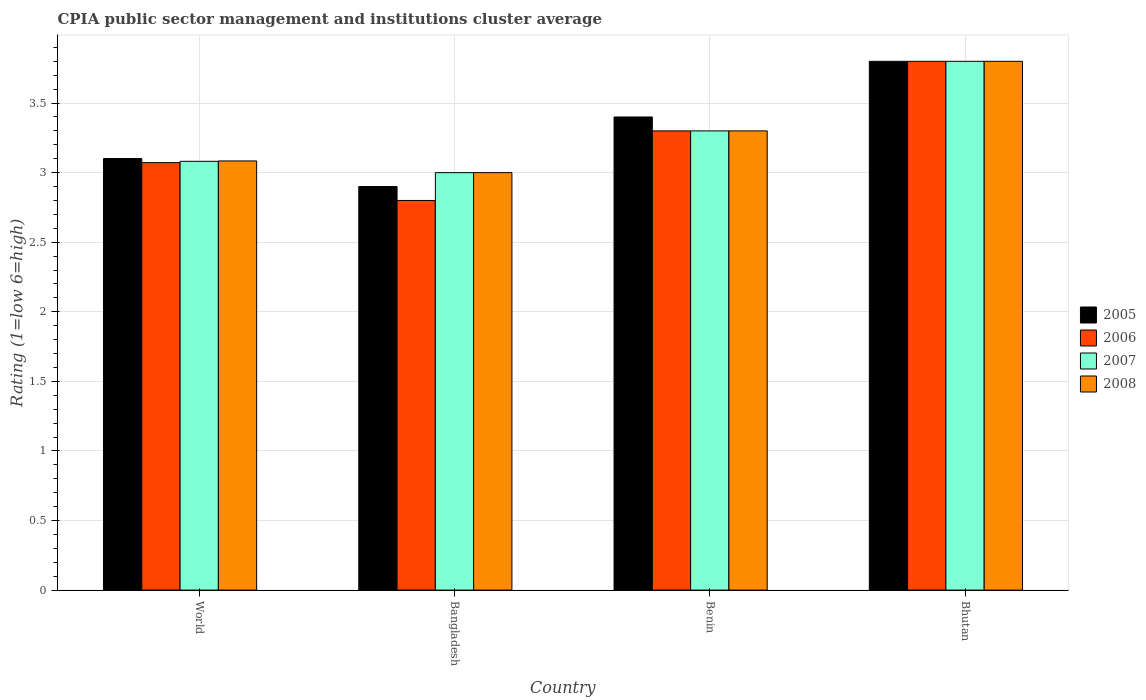How many groups of bars are there?
Give a very brief answer. 4. Are the number of bars per tick equal to the number of legend labels?
Your response must be concise. Yes. How many bars are there on the 1st tick from the right?
Provide a succinct answer. 4. What is the label of the 2nd group of bars from the left?
Provide a short and direct response. Bangladesh. What is the CPIA rating in 2006 in Benin?
Ensure brevity in your answer.  3.3. In which country was the CPIA rating in 2007 maximum?
Your answer should be very brief. Bhutan. What is the total CPIA rating in 2008 in the graph?
Give a very brief answer. 13.18. What is the difference between the CPIA rating in 2005 in Bhutan and that in World?
Ensure brevity in your answer.  0.7. What is the difference between the CPIA rating in 2007 in Bangladesh and the CPIA rating in 2006 in Bhutan?
Your response must be concise. -0.8. What is the average CPIA rating in 2006 per country?
Your answer should be compact. 3.24. In how many countries, is the CPIA rating in 2007 greater than 2.3?
Make the answer very short. 4. What is the ratio of the CPIA rating in 2007 in Bangladesh to that in Bhutan?
Keep it short and to the point. 0.79. Is the CPIA rating in 2007 in Bangladesh less than that in Bhutan?
Keep it short and to the point. Yes. Is the difference between the CPIA rating in 2007 in Bangladesh and World greater than the difference between the CPIA rating in 2008 in Bangladesh and World?
Provide a short and direct response. Yes. What is the difference between the highest and the second highest CPIA rating in 2005?
Provide a short and direct response. -0.4. What is the difference between the highest and the lowest CPIA rating in 2005?
Your answer should be compact. 0.9. Is it the case that in every country, the sum of the CPIA rating in 2006 and CPIA rating in 2007 is greater than the CPIA rating in 2005?
Your response must be concise. Yes. How many bars are there?
Offer a terse response. 16. Are all the bars in the graph horizontal?
Your answer should be compact. No. How many countries are there in the graph?
Make the answer very short. 4. What is the difference between two consecutive major ticks on the Y-axis?
Provide a succinct answer. 0.5. Are the values on the major ticks of Y-axis written in scientific E-notation?
Offer a very short reply. No. Does the graph contain any zero values?
Offer a very short reply. No. Does the graph contain grids?
Offer a terse response. Yes. How many legend labels are there?
Provide a succinct answer. 4. What is the title of the graph?
Ensure brevity in your answer.  CPIA public sector management and institutions cluster average. Does "1963" appear as one of the legend labels in the graph?
Offer a very short reply. No. What is the label or title of the Y-axis?
Provide a succinct answer. Rating (1=low 6=high). What is the Rating (1=low 6=high) of 2005 in World?
Your response must be concise. 3.1. What is the Rating (1=low 6=high) of 2006 in World?
Your answer should be very brief. 3.07. What is the Rating (1=low 6=high) of 2007 in World?
Provide a succinct answer. 3.08. What is the Rating (1=low 6=high) in 2008 in World?
Offer a terse response. 3.08. What is the Rating (1=low 6=high) of 2006 in Bangladesh?
Ensure brevity in your answer.  2.8. What is the Rating (1=low 6=high) of 2007 in Bangladesh?
Give a very brief answer. 3. What is the Rating (1=low 6=high) of 2008 in Bangladesh?
Your answer should be compact. 3. What is the Rating (1=low 6=high) in 2006 in Benin?
Your answer should be very brief. 3.3. What is the Rating (1=low 6=high) in 2008 in Benin?
Ensure brevity in your answer.  3.3. What is the Rating (1=low 6=high) in 2005 in Bhutan?
Ensure brevity in your answer.  3.8. What is the Rating (1=low 6=high) in 2008 in Bhutan?
Your answer should be very brief. 3.8. Across all countries, what is the maximum Rating (1=low 6=high) of 2005?
Your response must be concise. 3.8. Across all countries, what is the maximum Rating (1=low 6=high) in 2006?
Your answer should be very brief. 3.8. Across all countries, what is the minimum Rating (1=low 6=high) of 2006?
Offer a terse response. 2.8. Across all countries, what is the minimum Rating (1=low 6=high) in 2007?
Ensure brevity in your answer.  3. What is the total Rating (1=low 6=high) in 2005 in the graph?
Provide a succinct answer. 13.2. What is the total Rating (1=low 6=high) in 2006 in the graph?
Offer a very short reply. 12.97. What is the total Rating (1=low 6=high) of 2007 in the graph?
Your answer should be very brief. 13.18. What is the total Rating (1=low 6=high) of 2008 in the graph?
Your response must be concise. 13.18. What is the difference between the Rating (1=low 6=high) of 2005 in World and that in Bangladesh?
Make the answer very short. 0.2. What is the difference between the Rating (1=low 6=high) in 2006 in World and that in Bangladesh?
Offer a very short reply. 0.27. What is the difference between the Rating (1=low 6=high) of 2007 in World and that in Bangladesh?
Ensure brevity in your answer.  0.08. What is the difference between the Rating (1=low 6=high) in 2008 in World and that in Bangladesh?
Keep it short and to the point. 0.08. What is the difference between the Rating (1=low 6=high) in 2005 in World and that in Benin?
Provide a short and direct response. -0.3. What is the difference between the Rating (1=low 6=high) of 2006 in World and that in Benin?
Keep it short and to the point. -0.23. What is the difference between the Rating (1=low 6=high) in 2007 in World and that in Benin?
Provide a short and direct response. -0.22. What is the difference between the Rating (1=low 6=high) in 2008 in World and that in Benin?
Offer a terse response. -0.22. What is the difference between the Rating (1=low 6=high) of 2005 in World and that in Bhutan?
Give a very brief answer. -0.7. What is the difference between the Rating (1=low 6=high) of 2006 in World and that in Bhutan?
Make the answer very short. -0.73. What is the difference between the Rating (1=low 6=high) of 2007 in World and that in Bhutan?
Offer a very short reply. -0.72. What is the difference between the Rating (1=low 6=high) of 2008 in World and that in Bhutan?
Offer a very short reply. -0.72. What is the difference between the Rating (1=low 6=high) in 2006 in Bangladesh and that in Benin?
Keep it short and to the point. -0.5. What is the difference between the Rating (1=low 6=high) in 2007 in Bangladesh and that in Benin?
Your answer should be compact. -0.3. What is the difference between the Rating (1=low 6=high) in 2008 in Bangladesh and that in Benin?
Your answer should be compact. -0.3. What is the difference between the Rating (1=low 6=high) in 2005 in Bangladesh and that in Bhutan?
Make the answer very short. -0.9. What is the difference between the Rating (1=low 6=high) of 2006 in Bangladesh and that in Bhutan?
Provide a short and direct response. -1. What is the difference between the Rating (1=low 6=high) of 2007 in Bangladesh and that in Bhutan?
Offer a terse response. -0.8. What is the difference between the Rating (1=low 6=high) in 2008 in Bangladesh and that in Bhutan?
Your response must be concise. -0.8. What is the difference between the Rating (1=low 6=high) of 2005 in Benin and that in Bhutan?
Your response must be concise. -0.4. What is the difference between the Rating (1=low 6=high) in 2007 in Benin and that in Bhutan?
Offer a terse response. -0.5. What is the difference between the Rating (1=low 6=high) of 2008 in Benin and that in Bhutan?
Your response must be concise. -0.5. What is the difference between the Rating (1=low 6=high) of 2005 in World and the Rating (1=low 6=high) of 2006 in Bangladesh?
Provide a short and direct response. 0.3. What is the difference between the Rating (1=low 6=high) of 2005 in World and the Rating (1=low 6=high) of 2007 in Bangladesh?
Keep it short and to the point. 0.1. What is the difference between the Rating (1=low 6=high) in 2005 in World and the Rating (1=low 6=high) in 2008 in Bangladesh?
Ensure brevity in your answer.  0.1. What is the difference between the Rating (1=low 6=high) of 2006 in World and the Rating (1=low 6=high) of 2007 in Bangladesh?
Ensure brevity in your answer.  0.07. What is the difference between the Rating (1=low 6=high) of 2006 in World and the Rating (1=low 6=high) of 2008 in Bangladesh?
Keep it short and to the point. 0.07. What is the difference between the Rating (1=low 6=high) in 2007 in World and the Rating (1=low 6=high) in 2008 in Bangladesh?
Provide a short and direct response. 0.08. What is the difference between the Rating (1=low 6=high) in 2005 in World and the Rating (1=low 6=high) in 2006 in Benin?
Ensure brevity in your answer.  -0.2. What is the difference between the Rating (1=low 6=high) in 2005 in World and the Rating (1=low 6=high) in 2007 in Benin?
Keep it short and to the point. -0.2. What is the difference between the Rating (1=low 6=high) of 2005 in World and the Rating (1=low 6=high) of 2008 in Benin?
Give a very brief answer. -0.2. What is the difference between the Rating (1=low 6=high) in 2006 in World and the Rating (1=low 6=high) in 2007 in Benin?
Ensure brevity in your answer.  -0.23. What is the difference between the Rating (1=low 6=high) of 2006 in World and the Rating (1=low 6=high) of 2008 in Benin?
Give a very brief answer. -0.23. What is the difference between the Rating (1=low 6=high) of 2007 in World and the Rating (1=low 6=high) of 2008 in Benin?
Give a very brief answer. -0.22. What is the difference between the Rating (1=low 6=high) of 2005 in World and the Rating (1=low 6=high) of 2006 in Bhutan?
Offer a terse response. -0.7. What is the difference between the Rating (1=low 6=high) in 2005 in World and the Rating (1=low 6=high) in 2007 in Bhutan?
Offer a very short reply. -0.7. What is the difference between the Rating (1=low 6=high) in 2005 in World and the Rating (1=low 6=high) in 2008 in Bhutan?
Offer a very short reply. -0.7. What is the difference between the Rating (1=low 6=high) in 2006 in World and the Rating (1=low 6=high) in 2007 in Bhutan?
Give a very brief answer. -0.73. What is the difference between the Rating (1=low 6=high) in 2006 in World and the Rating (1=low 6=high) in 2008 in Bhutan?
Make the answer very short. -0.73. What is the difference between the Rating (1=low 6=high) in 2007 in World and the Rating (1=low 6=high) in 2008 in Bhutan?
Provide a succinct answer. -0.72. What is the difference between the Rating (1=low 6=high) in 2005 in Bangladesh and the Rating (1=low 6=high) in 2006 in Benin?
Keep it short and to the point. -0.4. What is the difference between the Rating (1=low 6=high) of 2005 in Bangladesh and the Rating (1=low 6=high) of 2007 in Benin?
Give a very brief answer. -0.4. What is the difference between the Rating (1=low 6=high) of 2006 in Bangladesh and the Rating (1=low 6=high) of 2008 in Benin?
Keep it short and to the point. -0.5. What is the difference between the Rating (1=low 6=high) of 2007 in Bangladesh and the Rating (1=low 6=high) of 2008 in Benin?
Give a very brief answer. -0.3. What is the difference between the Rating (1=low 6=high) of 2005 in Bangladesh and the Rating (1=low 6=high) of 2006 in Bhutan?
Provide a short and direct response. -0.9. What is the difference between the Rating (1=low 6=high) of 2005 in Bangladesh and the Rating (1=low 6=high) of 2008 in Bhutan?
Keep it short and to the point. -0.9. What is the difference between the Rating (1=low 6=high) of 2006 in Bangladesh and the Rating (1=low 6=high) of 2007 in Bhutan?
Make the answer very short. -1. What is the difference between the Rating (1=low 6=high) in 2005 in Benin and the Rating (1=low 6=high) in 2007 in Bhutan?
Offer a very short reply. -0.4. What is the difference between the Rating (1=low 6=high) of 2006 in Benin and the Rating (1=low 6=high) of 2007 in Bhutan?
Offer a very short reply. -0.5. What is the difference between the Rating (1=low 6=high) of 2006 in Benin and the Rating (1=low 6=high) of 2008 in Bhutan?
Give a very brief answer. -0.5. What is the difference between the Rating (1=low 6=high) of 2007 in Benin and the Rating (1=low 6=high) of 2008 in Bhutan?
Your answer should be very brief. -0.5. What is the average Rating (1=low 6=high) in 2005 per country?
Offer a terse response. 3.3. What is the average Rating (1=low 6=high) of 2006 per country?
Give a very brief answer. 3.24. What is the average Rating (1=low 6=high) in 2007 per country?
Provide a short and direct response. 3.3. What is the average Rating (1=low 6=high) of 2008 per country?
Your response must be concise. 3.3. What is the difference between the Rating (1=low 6=high) of 2005 and Rating (1=low 6=high) of 2006 in World?
Give a very brief answer. 0.03. What is the difference between the Rating (1=low 6=high) in 2005 and Rating (1=low 6=high) in 2007 in World?
Give a very brief answer. 0.02. What is the difference between the Rating (1=low 6=high) in 2005 and Rating (1=low 6=high) in 2008 in World?
Your answer should be very brief. 0.02. What is the difference between the Rating (1=low 6=high) of 2006 and Rating (1=low 6=high) of 2007 in World?
Ensure brevity in your answer.  -0.01. What is the difference between the Rating (1=low 6=high) in 2006 and Rating (1=low 6=high) in 2008 in World?
Give a very brief answer. -0.01. What is the difference between the Rating (1=low 6=high) in 2007 and Rating (1=low 6=high) in 2008 in World?
Provide a short and direct response. -0. What is the difference between the Rating (1=low 6=high) of 2005 and Rating (1=low 6=high) of 2006 in Bangladesh?
Give a very brief answer. 0.1. What is the difference between the Rating (1=low 6=high) of 2006 and Rating (1=low 6=high) of 2007 in Bangladesh?
Provide a succinct answer. -0.2. What is the difference between the Rating (1=low 6=high) in 2007 and Rating (1=low 6=high) in 2008 in Bangladesh?
Offer a very short reply. 0. What is the difference between the Rating (1=low 6=high) of 2005 and Rating (1=low 6=high) of 2006 in Benin?
Offer a very short reply. 0.1. What is the difference between the Rating (1=low 6=high) in 2005 and Rating (1=low 6=high) in 2007 in Benin?
Your response must be concise. 0.1. What is the difference between the Rating (1=low 6=high) in 2006 and Rating (1=low 6=high) in 2008 in Benin?
Provide a short and direct response. 0. What is the difference between the Rating (1=low 6=high) of 2007 and Rating (1=low 6=high) of 2008 in Benin?
Your answer should be very brief. 0. What is the difference between the Rating (1=low 6=high) of 2005 and Rating (1=low 6=high) of 2007 in Bhutan?
Your answer should be compact. 0. What is the difference between the Rating (1=low 6=high) in 2006 and Rating (1=low 6=high) in 2008 in Bhutan?
Offer a terse response. 0. What is the ratio of the Rating (1=low 6=high) of 2005 in World to that in Bangladesh?
Provide a short and direct response. 1.07. What is the ratio of the Rating (1=low 6=high) of 2006 in World to that in Bangladesh?
Give a very brief answer. 1.1. What is the ratio of the Rating (1=low 6=high) in 2007 in World to that in Bangladesh?
Give a very brief answer. 1.03. What is the ratio of the Rating (1=low 6=high) in 2008 in World to that in Bangladesh?
Provide a short and direct response. 1.03. What is the ratio of the Rating (1=low 6=high) of 2005 in World to that in Benin?
Keep it short and to the point. 0.91. What is the ratio of the Rating (1=low 6=high) in 2006 in World to that in Benin?
Keep it short and to the point. 0.93. What is the ratio of the Rating (1=low 6=high) of 2007 in World to that in Benin?
Your response must be concise. 0.93. What is the ratio of the Rating (1=low 6=high) of 2008 in World to that in Benin?
Give a very brief answer. 0.93. What is the ratio of the Rating (1=low 6=high) of 2005 in World to that in Bhutan?
Your answer should be very brief. 0.82. What is the ratio of the Rating (1=low 6=high) in 2006 in World to that in Bhutan?
Offer a terse response. 0.81. What is the ratio of the Rating (1=low 6=high) in 2007 in World to that in Bhutan?
Your response must be concise. 0.81. What is the ratio of the Rating (1=low 6=high) of 2008 in World to that in Bhutan?
Your answer should be very brief. 0.81. What is the ratio of the Rating (1=low 6=high) of 2005 in Bangladesh to that in Benin?
Offer a very short reply. 0.85. What is the ratio of the Rating (1=low 6=high) of 2006 in Bangladesh to that in Benin?
Give a very brief answer. 0.85. What is the ratio of the Rating (1=low 6=high) in 2007 in Bangladesh to that in Benin?
Ensure brevity in your answer.  0.91. What is the ratio of the Rating (1=low 6=high) in 2008 in Bangladesh to that in Benin?
Make the answer very short. 0.91. What is the ratio of the Rating (1=low 6=high) in 2005 in Bangladesh to that in Bhutan?
Keep it short and to the point. 0.76. What is the ratio of the Rating (1=low 6=high) of 2006 in Bangladesh to that in Bhutan?
Your answer should be very brief. 0.74. What is the ratio of the Rating (1=low 6=high) of 2007 in Bangladesh to that in Bhutan?
Give a very brief answer. 0.79. What is the ratio of the Rating (1=low 6=high) of 2008 in Bangladesh to that in Bhutan?
Provide a short and direct response. 0.79. What is the ratio of the Rating (1=low 6=high) in 2005 in Benin to that in Bhutan?
Provide a succinct answer. 0.89. What is the ratio of the Rating (1=low 6=high) of 2006 in Benin to that in Bhutan?
Your response must be concise. 0.87. What is the ratio of the Rating (1=low 6=high) of 2007 in Benin to that in Bhutan?
Offer a terse response. 0.87. What is the ratio of the Rating (1=low 6=high) in 2008 in Benin to that in Bhutan?
Give a very brief answer. 0.87. What is the difference between the highest and the second highest Rating (1=low 6=high) in 2005?
Your answer should be compact. 0.4. What is the difference between the highest and the second highest Rating (1=low 6=high) of 2006?
Offer a very short reply. 0.5. What is the difference between the highest and the lowest Rating (1=low 6=high) in 2007?
Make the answer very short. 0.8. What is the difference between the highest and the lowest Rating (1=low 6=high) in 2008?
Your answer should be very brief. 0.8. 